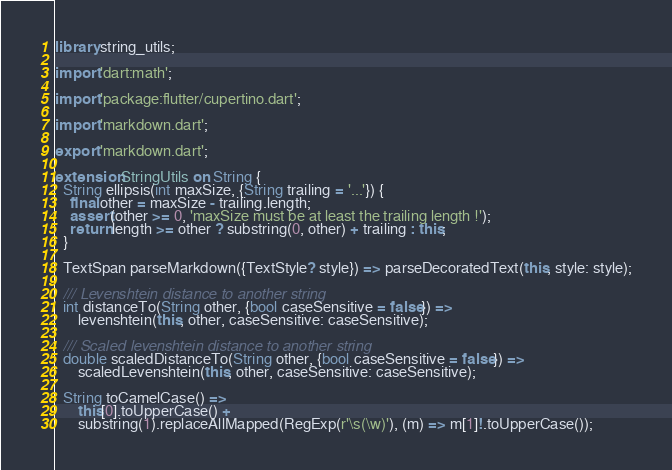<code> <loc_0><loc_0><loc_500><loc_500><_Dart_>library string_utils;

import 'dart:math';

import 'package:flutter/cupertino.dart';

import 'markdown.dart';

export 'markdown.dart';

extension StringUtils on String {
  String ellipsis(int maxSize, {String trailing = '...'}) {
    final other = maxSize - trailing.length;
    assert(other >= 0, 'maxSize must be at least the trailing length !');
    return length >= other ? substring(0, other) + trailing : this;
  }

  TextSpan parseMarkdown({TextStyle? style}) => parseDecoratedText(this, style: style);

  /// Levenshtein distance to another string
  int distanceTo(String other, {bool caseSensitive = false}) =>
      levenshtein(this, other, caseSensitive: caseSensitive);

  /// Scaled levenshtein distance to another string
  double scaledDistanceTo(String other, {bool caseSensitive = false}) =>
      scaledLevenshtein(this, other, caseSensitive: caseSensitive);

  String toCamelCase() =>
      this[0].toUpperCase() +
      substring(1).replaceAllMapped(RegExp(r'\s(\w)'), (m) => m[1]!.toUpperCase());
</code> 